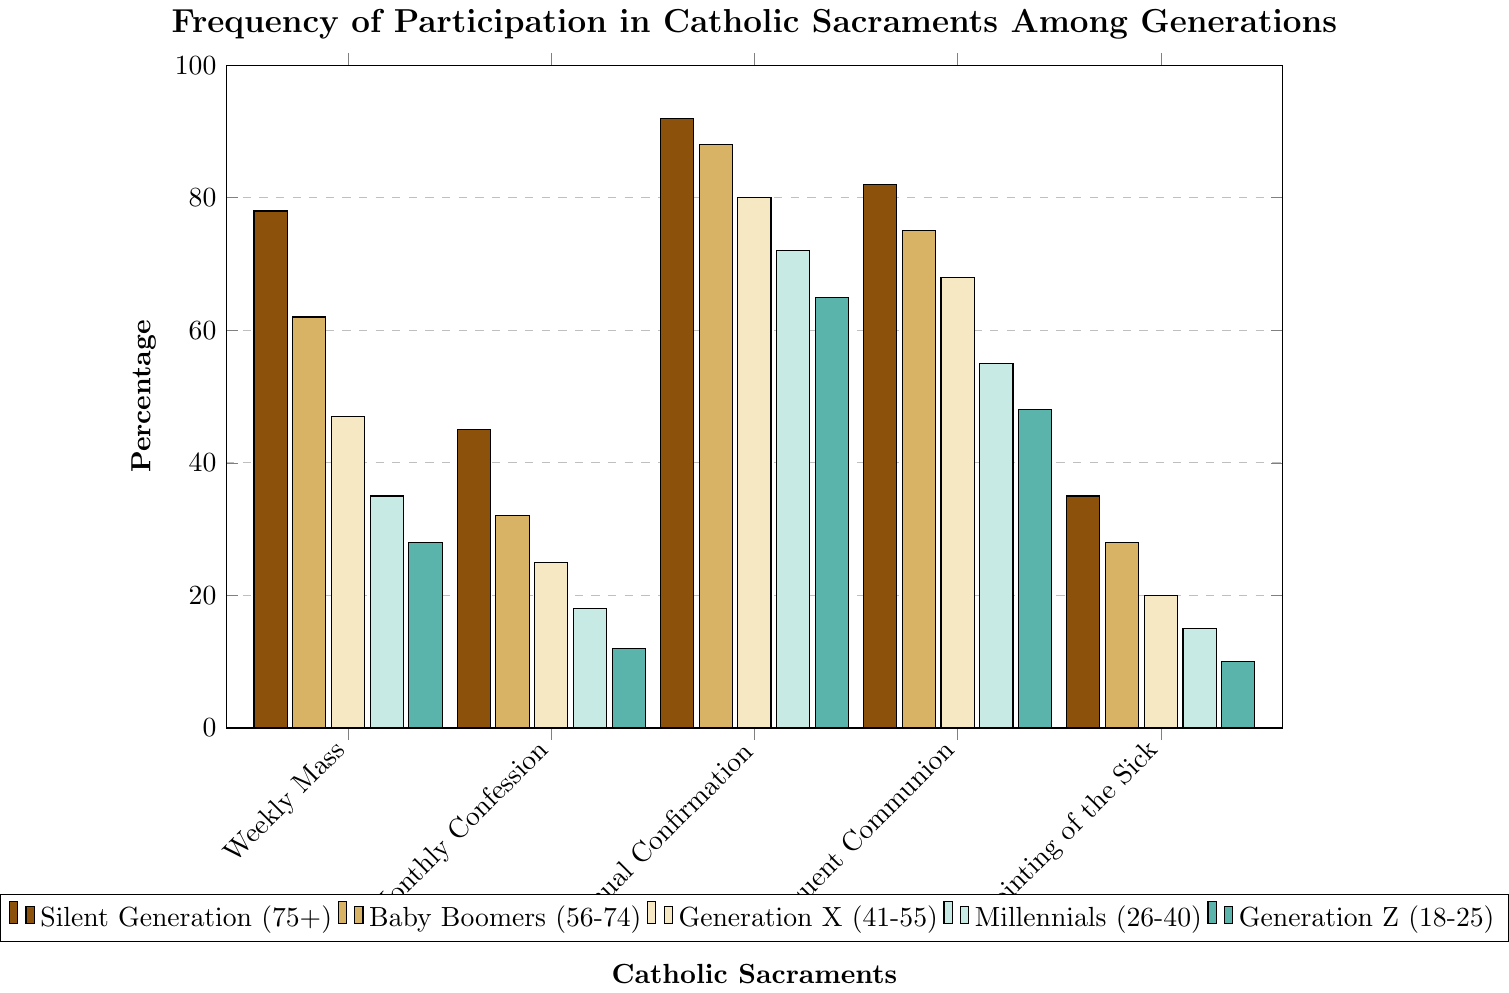What's the percentage of Millennials who participate in Weekly Mass and Monthly Confession combined? First, identify the participation percentage for Millennials in Weekly Mass, which is 35%, and in Monthly Confession, which is 18%. Next, add these percentages together: 35% + 18% = 53%.
Answer: 53% Which generation has the lowest percentage of participation in Monthly Confession? Examine the bars for Monthly Confession across all generations. The percentage values are: Silent Generation (45%), Baby Boomers (32%), Generation X (25%), Millennials (18%), and Generation Z (12%). Generation Z has the lowest percentage at 12%.
Answer: Generation Z Compare the amount by which the Silent Generation's participation in Weekly Mass exceeds that of Generation X. The Silent Generation's participation in Weekly Mass is 78%, and Generation X's is 47%. Subtract Generation X’s percentage from the Silent Generation’s percentage: 78% - 47% = 31%.
Answer: 31% Among all the sacraments, which one has the highest participation rate for Generation X? Review each bar representing Generation X across different sacraments. The values are: Weekly Mass (47%), Monthly Confession (25%), Annual Confirmation (80%), Frequent Communion (68%), and Anointing of the Sick (20%). The highest is Annual Confirmation with 80%.
Answer: Annual Confirmation What is the average participation rate in Anointing of the Sick for all generations? First, sum the percentages for Anointing of the Sick: 35% (Silent Generation) + 28% (Baby Boomers) + 20% (Generation X) + 15% (Millennials) + 10% (Generation Z) = 108%. Then, divide by the number of generations (5): 108% / 5 = 21.6%.
Answer: 21.6% By how much does the percentage of Silent Generation participating in Frequent Communion exceed that of Millennials? The Silent Generation's participation in Frequent Communion is 82%, and Millennials' is 55%. Subtract the Millennials’ percentage from the Silent Generation’s percentage: 82% - 55% = 27%.
Answer: 27% Is the participation in Annual Confirmation greater than the participation in Weekly Mass for Baby Boomers? Compare the two percentages for Baby Boomers: Annual Confirmation (88%) and Weekly Mass (62%). 88% is greater than 62%.
Answer: Yes What is the difference between the highest and lowest percentage of participation in any sacrament for Generation Z? The percentages for Generation Z are Weekly Mass (28%), Monthly Confession (12%), Annual Confirmation (65%), Frequent Communion (48%), and Anointing of the Sick (10%). The highest is 65% (Annual Confirmation) and the lowest is 10% (Anointing of the Sick). Subtract the lowest percentage from the highest percentage: 65% - 10% = 55%.
Answer: 55% Which sacrament shows the most consistent participation rate (smallest range of percentages) across all generations? Review the range of participation percentages for each sacrament: Weekly Mass ranges from 28% to 78% (range = 50%), Monthly Confession from 12% to 45% (range = 33%), Annual Confirmation from 65% to 92% (range = 27%), Frequent Communion from 48% to 82% (range = 34%), and Anointing of the Sick from 10% to 35% (range = 25%). The smallest range is for Anointing of the Sick with a range of 25%.
Answer: Anointing of the Sick What color represents the Millennials in the figure? Refer to the legend in the figure to identify the color associated with Millennials. The corresponding color for Millennials is green.
Answer: Green 